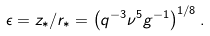<formula> <loc_0><loc_0><loc_500><loc_500>\epsilon = z _ { * } / r _ { * } = \left ( q ^ { - 3 } \nu ^ { 5 } g ^ { - 1 } \right ) ^ { 1 / 8 } .</formula> 